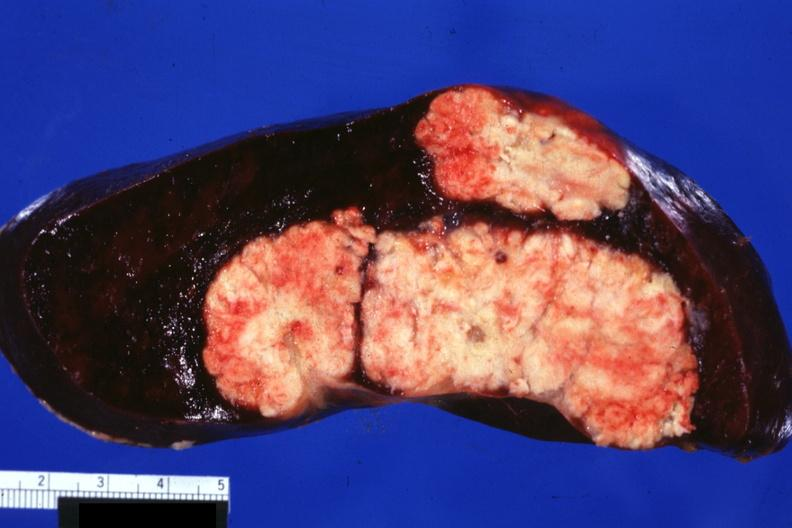where is this part in?
Answer the question using a single word or phrase. Spleen 